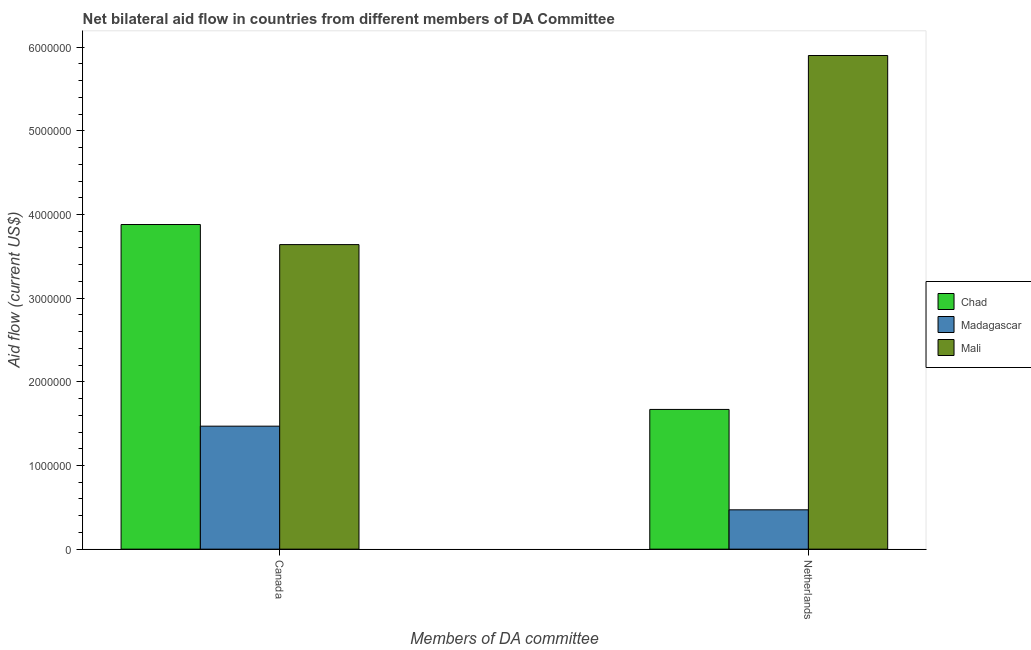How many different coloured bars are there?
Your response must be concise. 3. How many groups of bars are there?
Ensure brevity in your answer.  2. Are the number of bars per tick equal to the number of legend labels?
Your response must be concise. Yes. Are the number of bars on each tick of the X-axis equal?
Provide a short and direct response. Yes. How many bars are there on the 1st tick from the left?
Give a very brief answer. 3. What is the label of the 2nd group of bars from the left?
Your answer should be very brief. Netherlands. What is the amount of aid given by canada in Madagascar?
Provide a succinct answer. 1.47e+06. Across all countries, what is the maximum amount of aid given by netherlands?
Your response must be concise. 5.90e+06. Across all countries, what is the minimum amount of aid given by netherlands?
Your answer should be compact. 4.70e+05. In which country was the amount of aid given by canada maximum?
Your response must be concise. Chad. In which country was the amount of aid given by netherlands minimum?
Make the answer very short. Madagascar. What is the total amount of aid given by canada in the graph?
Your response must be concise. 8.99e+06. What is the difference between the amount of aid given by netherlands in Mali and that in Chad?
Your answer should be very brief. 4.23e+06. What is the difference between the amount of aid given by canada in Chad and the amount of aid given by netherlands in Mali?
Provide a succinct answer. -2.02e+06. What is the average amount of aid given by canada per country?
Your answer should be very brief. 3.00e+06. What is the difference between the amount of aid given by canada and amount of aid given by netherlands in Madagascar?
Offer a terse response. 1.00e+06. What is the ratio of the amount of aid given by netherlands in Chad to that in Mali?
Offer a terse response. 0.28. In how many countries, is the amount of aid given by netherlands greater than the average amount of aid given by netherlands taken over all countries?
Your answer should be compact. 1. What does the 1st bar from the left in Netherlands represents?
Make the answer very short. Chad. What does the 2nd bar from the right in Netherlands represents?
Make the answer very short. Madagascar. How many bars are there?
Provide a short and direct response. 6. Are all the bars in the graph horizontal?
Ensure brevity in your answer.  No. How many countries are there in the graph?
Give a very brief answer. 3. Where does the legend appear in the graph?
Give a very brief answer. Center right. How many legend labels are there?
Your response must be concise. 3. How are the legend labels stacked?
Provide a succinct answer. Vertical. What is the title of the graph?
Offer a terse response. Net bilateral aid flow in countries from different members of DA Committee. Does "Australia" appear as one of the legend labels in the graph?
Give a very brief answer. No. What is the label or title of the X-axis?
Your answer should be compact. Members of DA committee. What is the label or title of the Y-axis?
Your answer should be compact. Aid flow (current US$). What is the Aid flow (current US$) in Chad in Canada?
Your response must be concise. 3.88e+06. What is the Aid flow (current US$) in Madagascar in Canada?
Keep it short and to the point. 1.47e+06. What is the Aid flow (current US$) in Mali in Canada?
Your answer should be very brief. 3.64e+06. What is the Aid flow (current US$) of Chad in Netherlands?
Offer a terse response. 1.67e+06. What is the Aid flow (current US$) of Madagascar in Netherlands?
Provide a succinct answer. 4.70e+05. What is the Aid flow (current US$) in Mali in Netherlands?
Your response must be concise. 5.90e+06. Across all Members of DA committee, what is the maximum Aid flow (current US$) in Chad?
Offer a very short reply. 3.88e+06. Across all Members of DA committee, what is the maximum Aid flow (current US$) in Madagascar?
Offer a terse response. 1.47e+06. Across all Members of DA committee, what is the maximum Aid flow (current US$) in Mali?
Your answer should be compact. 5.90e+06. Across all Members of DA committee, what is the minimum Aid flow (current US$) of Chad?
Provide a succinct answer. 1.67e+06. Across all Members of DA committee, what is the minimum Aid flow (current US$) of Mali?
Your answer should be very brief. 3.64e+06. What is the total Aid flow (current US$) in Chad in the graph?
Make the answer very short. 5.55e+06. What is the total Aid flow (current US$) in Madagascar in the graph?
Provide a short and direct response. 1.94e+06. What is the total Aid flow (current US$) of Mali in the graph?
Your answer should be compact. 9.54e+06. What is the difference between the Aid flow (current US$) of Chad in Canada and that in Netherlands?
Ensure brevity in your answer.  2.21e+06. What is the difference between the Aid flow (current US$) of Madagascar in Canada and that in Netherlands?
Your response must be concise. 1.00e+06. What is the difference between the Aid flow (current US$) of Mali in Canada and that in Netherlands?
Your response must be concise. -2.26e+06. What is the difference between the Aid flow (current US$) in Chad in Canada and the Aid flow (current US$) in Madagascar in Netherlands?
Your answer should be compact. 3.41e+06. What is the difference between the Aid flow (current US$) in Chad in Canada and the Aid flow (current US$) in Mali in Netherlands?
Make the answer very short. -2.02e+06. What is the difference between the Aid flow (current US$) of Madagascar in Canada and the Aid flow (current US$) of Mali in Netherlands?
Your answer should be compact. -4.43e+06. What is the average Aid flow (current US$) of Chad per Members of DA committee?
Make the answer very short. 2.78e+06. What is the average Aid flow (current US$) in Madagascar per Members of DA committee?
Offer a very short reply. 9.70e+05. What is the average Aid flow (current US$) in Mali per Members of DA committee?
Offer a very short reply. 4.77e+06. What is the difference between the Aid flow (current US$) of Chad and Aid flow (current US$) of Madagascar in Canada?
Offer a terse response. 2.41e+06. What is the difference between the Aid flow (current US$) of Madagascar and Aid flow (current US$) of Mali in Canada?
Your response must be concise. -2.17e+06. What is the difference between the Aid flow (current US$) in Chad and Aid flow (current US$) in Madagascar in Netherlands?
Keep it short and to the point. 1.20e+06. What is the difference between the Aid flow (current US$) of Chad and Aid flow (current US$) of Mali in Netherlands?
Offer a very short reply. -4.23e+06. What is the difference between the Aid flow (current US$) in Madagascar and Aid flow (current US$) in Mali in Netherlands?
Offer a terse response. -5.43e+06. What is the ratio of the Aid flow (current US$) in Chad in Canada to that in Netherlands?
Make the answer very short. 2.32. What is the ratio of the Aid flow (current US$) of Madagascar in Canada to that in Netherlands?
Provide a succinct answer. 3.13. What is the ratio of the Aid flow (current US$) of Mali in Canada to that in Netherlands?
Make the answer very short. 0.62. What is the difference between the highest and the second highest Aid flow (current US$) of Chad?
Your response must be concise. 2.21e+06. What is the difference between the highest and the second highest Aid flow (current US$) in Mali?
Make the answer very short. 2.26e+06. What is the difference between the highest and the lowest Aid flow (current US$) of Chad?
Your answer should be very brief. 2.21e+06. What is the difference between the highest and the lowest Aid flow (current US$) of Mali?
Your answer should be very brief. 2.26e+06. 